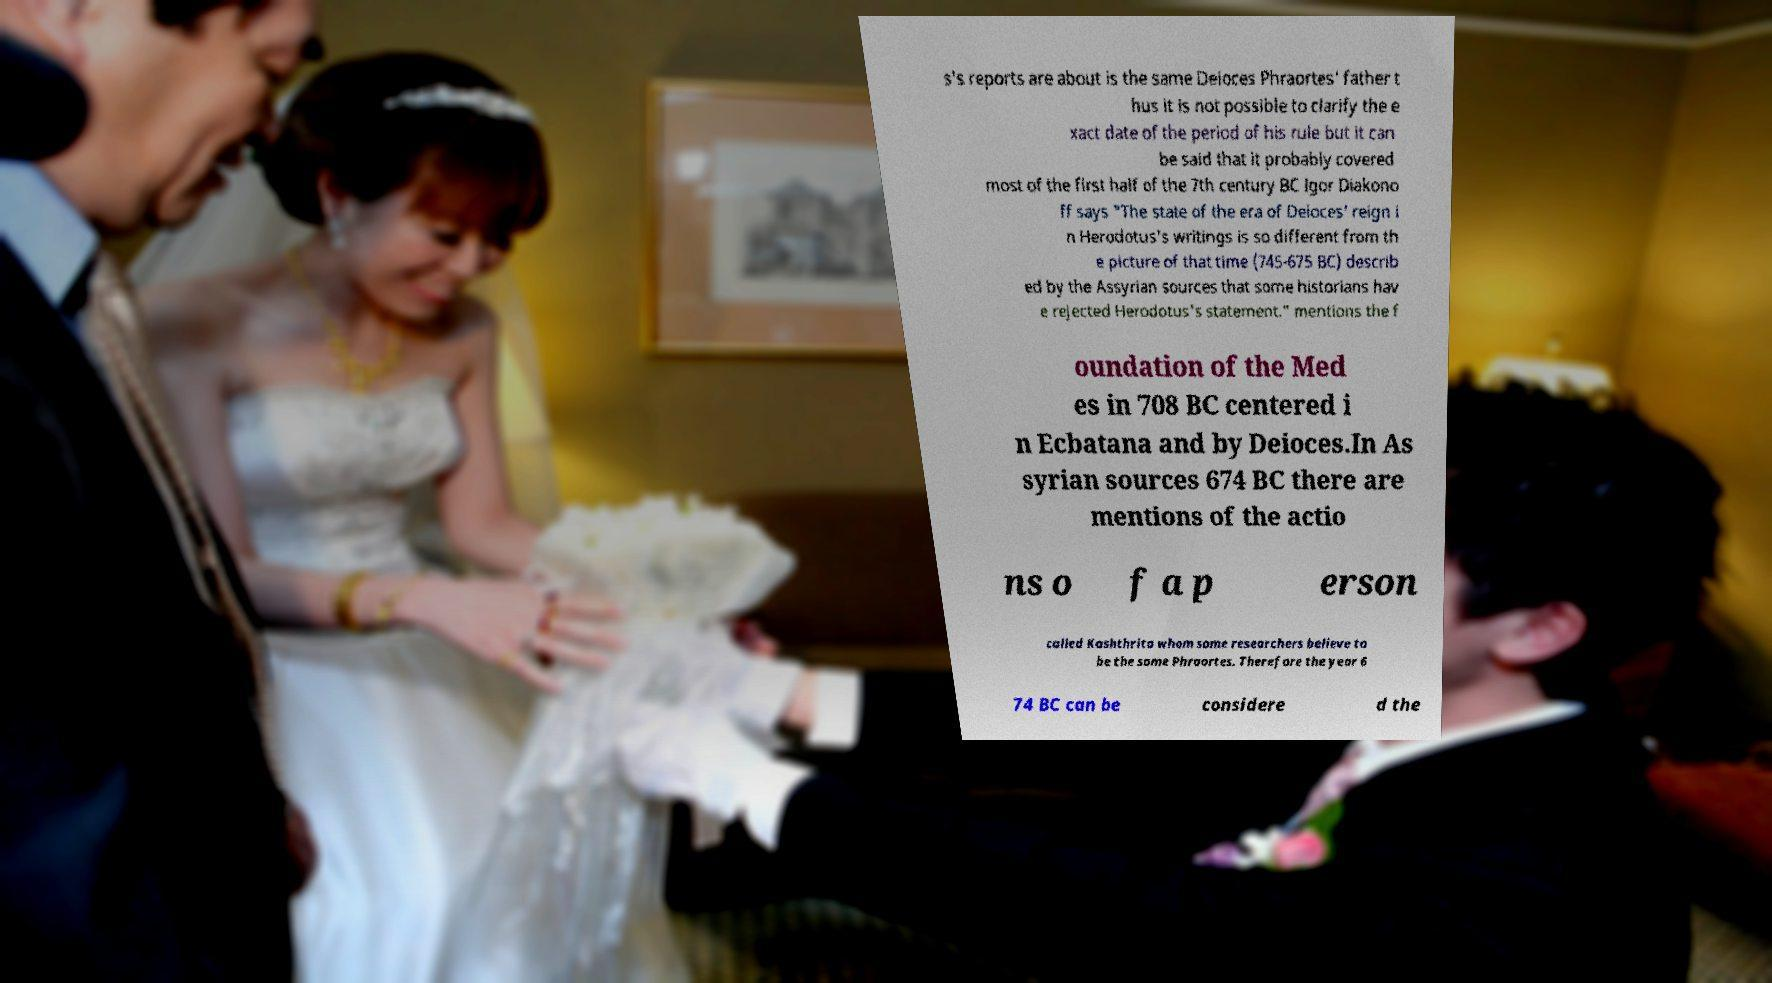Can you accurately transcribe the text from the provided image for me? s's reports are about is the same Deioces Phraortes' father t hus it is not possible to clarify the e xact date of the period of his rule but it can be said that it probably covered most of the first half of the 7th century BC Igor Diakono ff says "The state of the era of Deioces' reign i n Herodotus's writings is so different from th e picture of that time (745-675 BC) describ ed by the Assyrian sources that some historians hav e rejected Herodotus's statement." mentions the f oundation of the Med es in 708 BC centered i n Ecbatana and by Deioces.In As syrian sources 674 BC there are mentions of the actio ns o f a p erson called Kashthrita whom some researchers believe to be the same Phraortes. Therefore the year 6 74 BC can be considere d the 